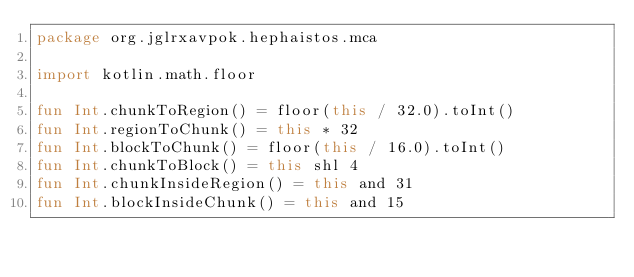Convert code to text. <code><loc_0><loc_0><loc_500><loc_500><_Kotlin_>package org.jglrxavpok.hephaistos.mca

import kotlin.math.floor

fun Int.chunkToRegion() = floor(this / 32.0).toInt()
fun Int.regionToChunk() = this * 32
fun Int.blockToChunk() = floor(this / 16.0).toInt()
fun Int.chunkToBlock() = this shl 4
fun Int.chunkInsideRegion() = this and 31
fun Int.blockInsideChunk() = this and 15</code> 